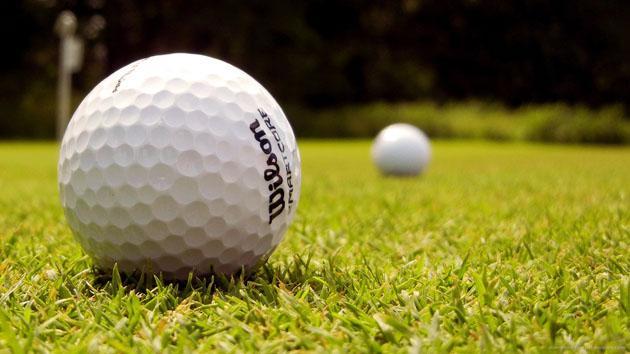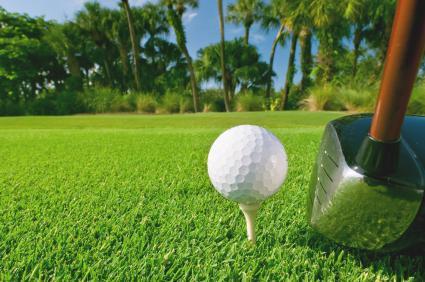The first image is the image on the left, the second image is the image on the right. Assess this claim about the two images: "In the right image, a single golf ball on a tee and part of a golf club are visible". Correct or not? Answer yes or no. Yes. 